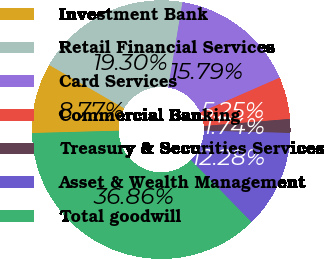Convert chart to OTSL. <chart><loc_0><loc_0><loc_500><loc_500><pie_chart><fcel>Investment Bank<fcel>Retail Financial Services<fcel>Card Services<fcel>Commercial Banking<fcel>Treasury & Securities Services<fcel>Asset & Wealth Management<fcel>Total goodwill<nl><fcel>8.77%<fcel>19.3%<fcel>15.79%<fcel>5.25%<fcel>1.74%<fcel>12.28%<fcel>36.86%<nl></chart> 